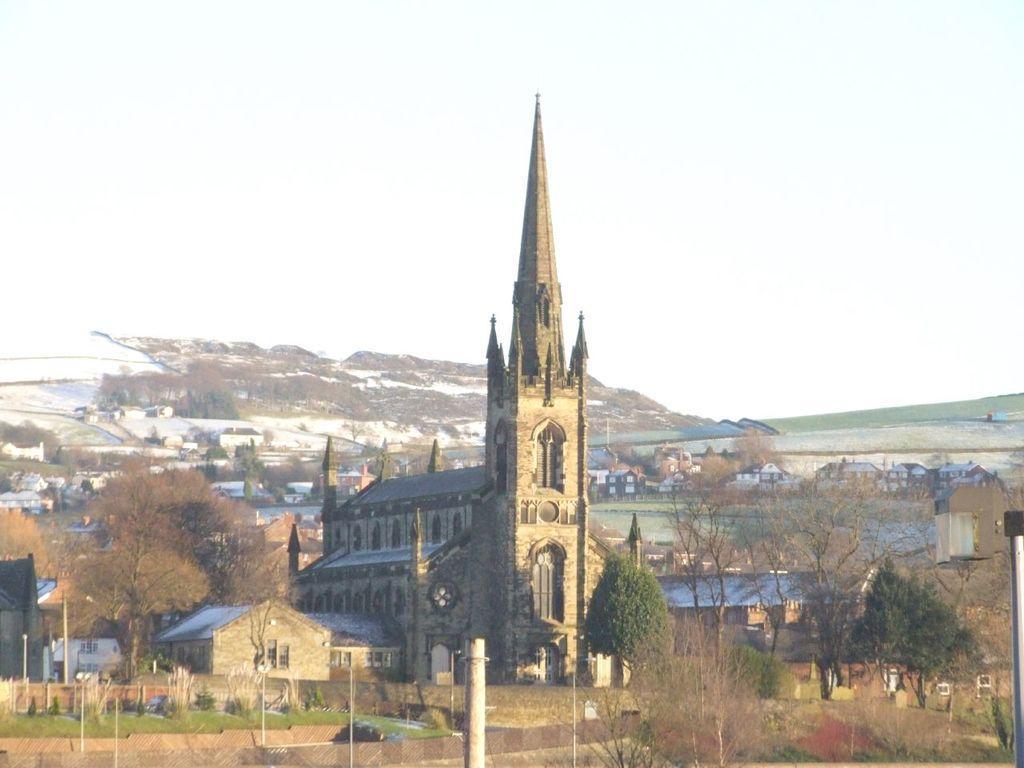Please provide a concise description of this image. In the image there is a castle in the middle with houses and buildings on either side and in the background with trees in front of them, all over the place. In the back there is a hill covered with snow and trees and above its sky. 